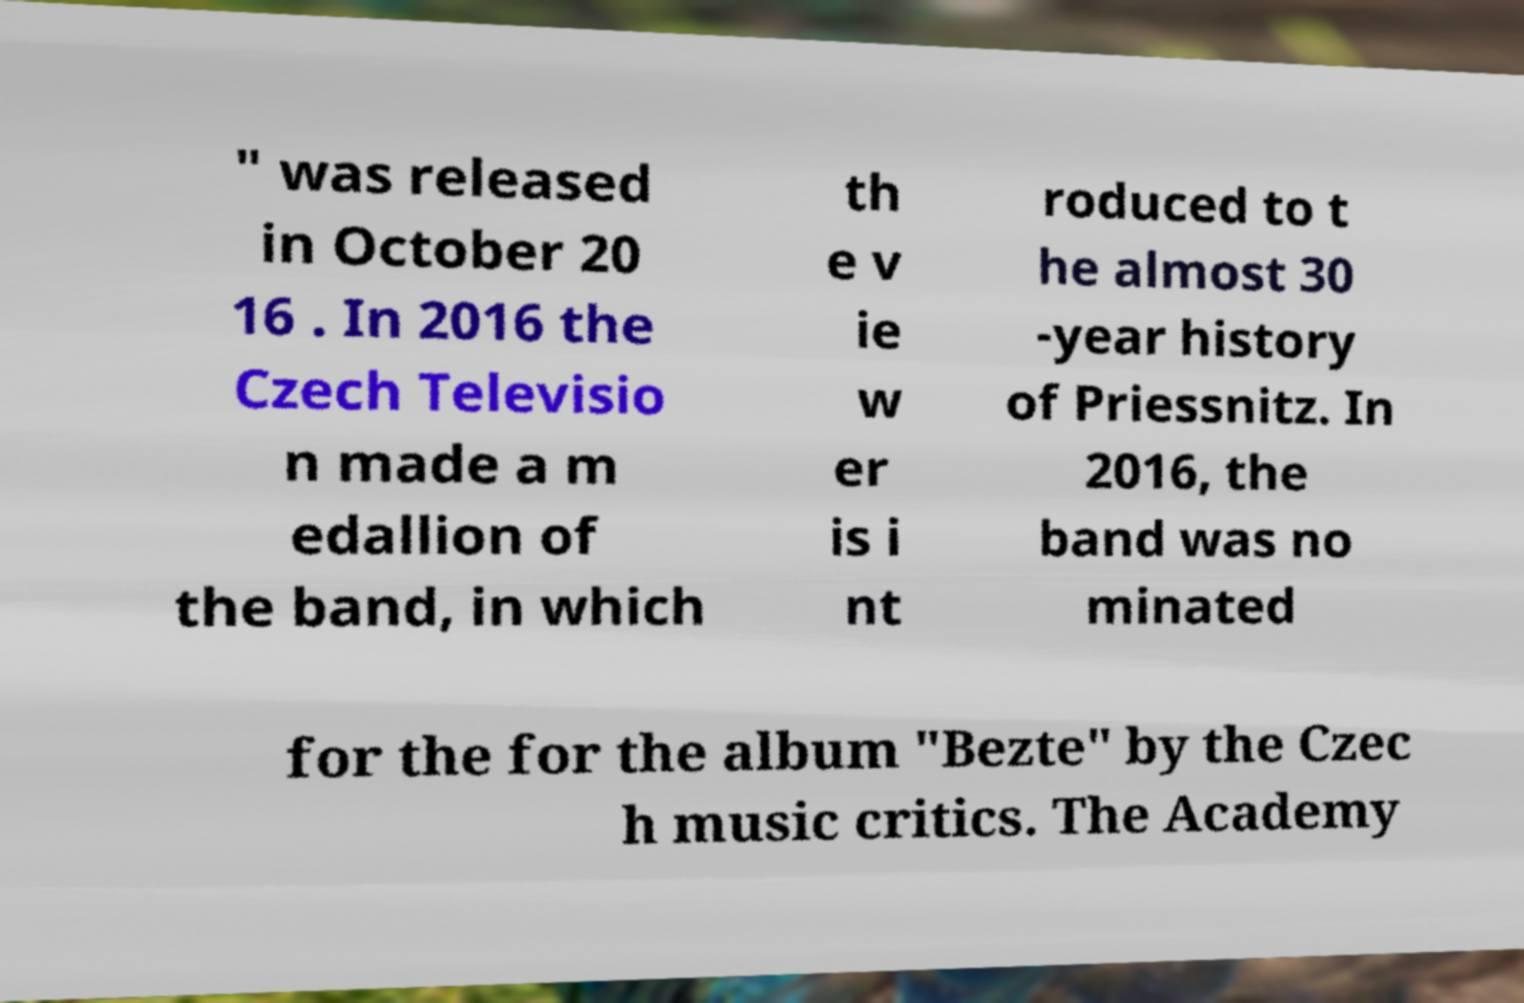Can you read and provide the text displayed in the image?This photo seems to have some interesting text. Can you extract and type it out for me? " was released in October 20 16 . In 2016 the Czech Televisio n made a m edallion of the band, in which th e v ie w er is i nt roduced to t he almost 30 -year history of Priessnitz. In 2016, the band was no minated for the for the album "Bezte" by the Czec h music critics. The Academy 